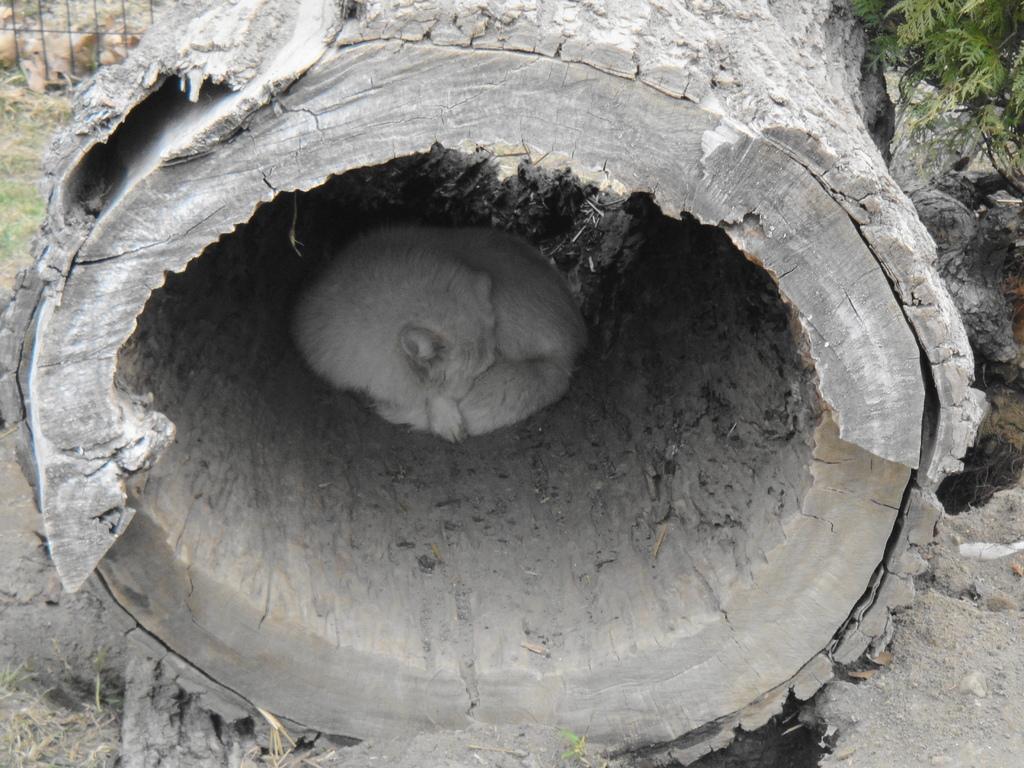In one or two sentences, can you explain what this image depicts? In this picture there is a dog sitting inside the tree trunk. At the back there is a fence and there is a plant. At the bottom there is ground and there is grass. 